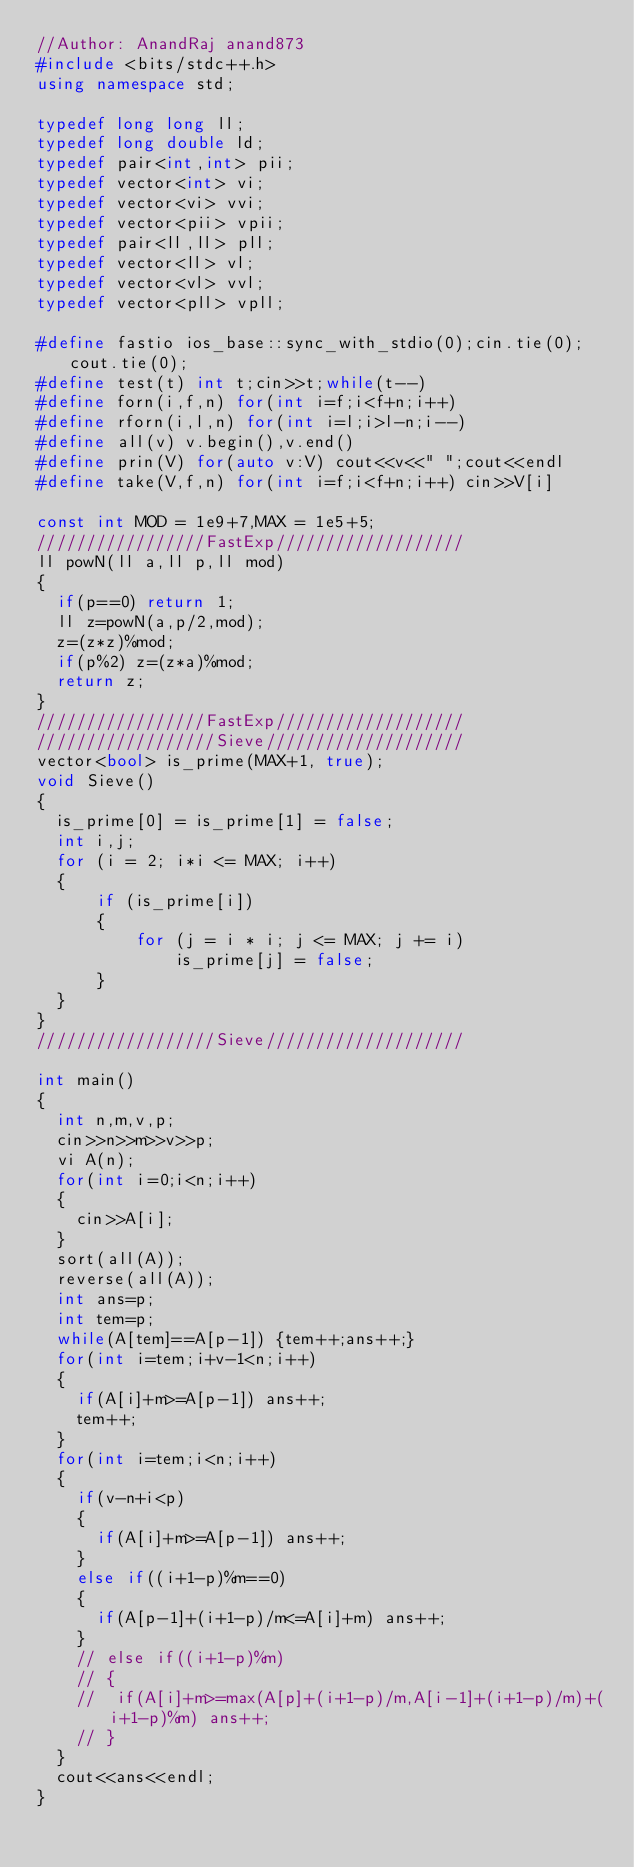<code> <loc_0><loc_0><loc_500><loc_500><_C++_>//Author: AnandRaj anand873
#include <bits/stdc++.h>
using namespace std;

typedef long long ll;
typedef long double ld;
typedef pair<int,int> pii;
typedef vector<int> vi;
typedef vector<vi> vvi;
typedef vector<pii> vpii;
typedef pair<ll,ll> pll;
typedef vector<ll> vl;
typedef vector<vl> vvl;
typedef vector<pll> vpll; 
 
#define fastio ios_base::sync_with_stdio(0);cin.tie(0);cout.tie(0);
#define test(t) int t;cin>>t;while(t--)
#define forn(i,f,n) for(int i=f;i<f+n;i++)
#define rforn(i,l,n) for(int i=l;i>l-n;i--)
#define all(v) v.begin(),v.end()
#define prin(V) for(auto v:V) cout<<v<<" ";cout<<endl
#define take(V,f,n) for(int i=f;i<f+n;i++) cin>>V[i]
 
const int MOD = 1e9+7,MAX = 1e5+5;
/////////////////FastExp///////////////////
ll powN(ll a,ll p,ll mod)
{
	if(p==0) return 1;
	ll z=powN(a,p/2,mod);
	z=(z*z)%mod;
	if(p%2) z=(z*a)%mod;
	return z;
}
/////////////////FastExp///////////////////
//////////////////Sieve////////////////////
vector<bool> is_prime(MAX+1, true);
void Sieve()
{
	is_prime[0] = is_prime[1] = false;
	int i,j;
	for (i = 2; i*i <= MAX; i++) 
	{
    	if (is_prime[i]) 
    	{
        	for (j = i * i; j <= MAX; j += i)
            	is_prime[j] = false;
    	}
	}
}
//////////////////Sieve////////////////////

int main()
{		
	int n,m,v,p;
	cin>>n>>m>>v>>p;
	vi A(n);
	for(int i=0;i<n;i++)
	{
		cin>>A[i];
	}
	sort(all(A));
	reverse(all(A));
	int ans=p;
	int tem=p;
	while(A[tem]==A[p-1]) {tem++;ans++;}
	for(int i=tem;i+v-1<n;i++)
	{
		if(A[i]+m>=A[p-1]) ans++;
		tem++;
	}
	for(int i=tem;i<n;i++)
	{
		if(v-n+i<p)
		{
			if(A[i]+m>=A[p-1]) ans++;
		}
		else if((i+1-p)%m==0)
		{
			if(A[p-1]+(i+1-p)/m<=A[i]+m) ans++;
		}
		// else if((i+1-p)%m)
		// {
		// 	if(A[i]+m>=max(A[p]+(i+1-p)/m,A[i-1]+(i+1-p)/m)+(i+1-p)%m) ans++;
		// }
	}
	cout<<ans<<endl;
}</code> 